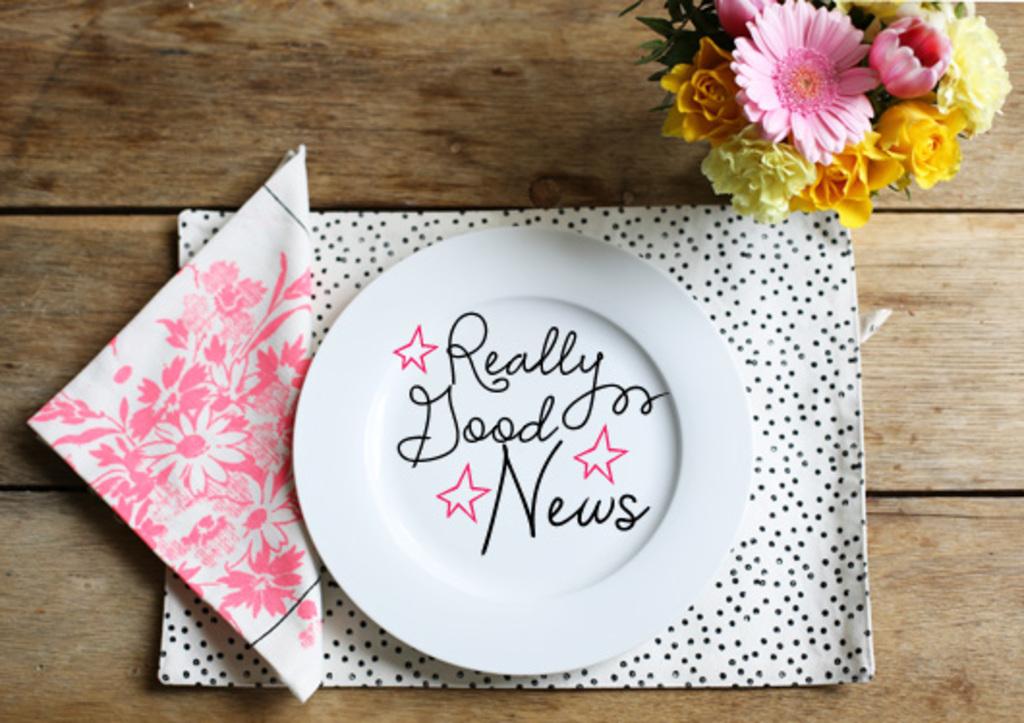What is written on this plate?
Keep it short and to the point. Really good news. Is the person eating here expecting bad news?
Keep it short and to the point. No. 